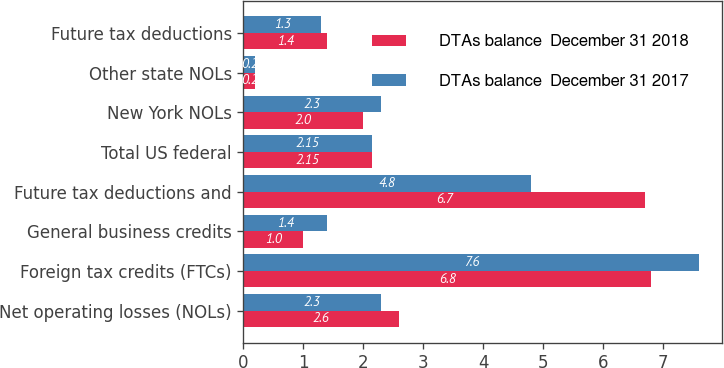<chart> <loc_0><loc_0><loc_500><loc_500><stacked_bar_chart><ecel><fcel>Net operating losses (NOLs)<fcel>Foreign tax credits (FTCs)<fcel>General business credits<fcel>Future tax deductions and<fcel>Total US federal<fcel>New York NOLs<fcel>Other state NOLs<fcel>Future tax deductions<nl><fcel>DTAs balance  December 31 2018<fcel>2.6<fcel>6.8<fcel>1<fcel>6.7<fcel>2.15<fcel>2<fcel>0.2<fcel>1.4<nl><fcel>DTAs balance  December 31 2017<fcel>2.3<fcel>7.6<fcel>1.4<fcel>4.8<fcel>2.15<fcel>2.3<fcel>0.2<fcel>1.3<nl></chart> 